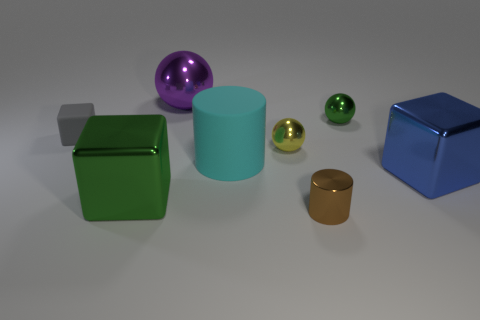Subtract all purple metallic spheres. How many spheres are left? 2 Subtract all yellow spheres. How many spheres are left? 2 Subtract 1 spheres. How many spheres are left? 2 Add 1 metallic balls. How many objects exist? 9 Subtract all yellow blocks. Subtract all blue spheres. How many blocks are left? 3 Subtract all spheres. How many objects are left? 5 Subtract 0 gray cylinders. How many objects are left? 8 Subtract all big yellow cylinders. Subtract all yellow metallic things. How many objects are left? 7 Add 7 large blue metallic objects. How many large blue metallic objects are left? 8 Add 3 green shiny blocks. How many green shiny blocks exist? 4 